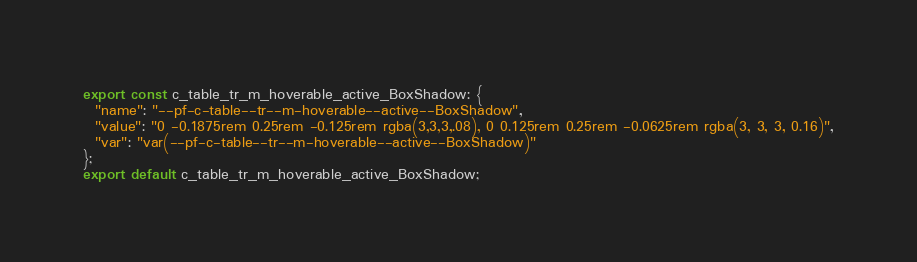<code> <loc_0><loc_0><loc_500><loc_500><_TypeScript_>export const c_table_tr_m_hoverable_active_BoxShadow: {
  "name": "--pf-c-table--tr--m-hoverable--active--BoxShadow",
  "value": "0 -0.1875rem 0.25rem -0.125rem rgba(3,3,3,.08), 0 0.125rem 0.25rem -0.0625rem rgba(3, 3, 3, 0.16)",
  "var": "var(--pf-c-table--tr--m-hoverable--active--BoxShadow)"
};
export default c_table_tr_m_hoverable_active_BoxShadow;</code> 